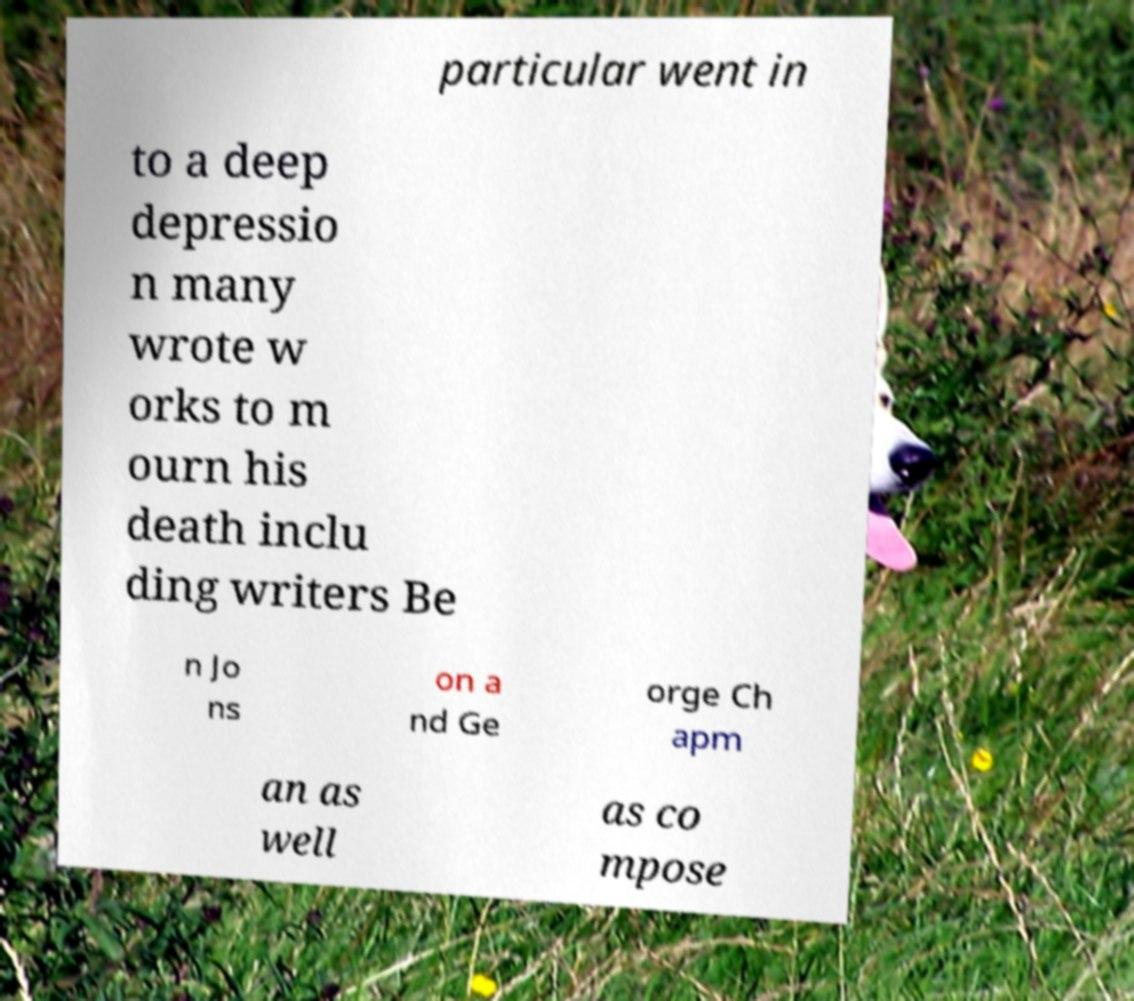Can you read and provide the text displayed in the image?This photo seems to have some interesting text. Can you extract and type it out for me? particular went in to a deep depressio n many wrote w orks to m ourn his death inclu ding writers Be n Jo ns on a nd Ge orge Ch apm an as well as co mpose 